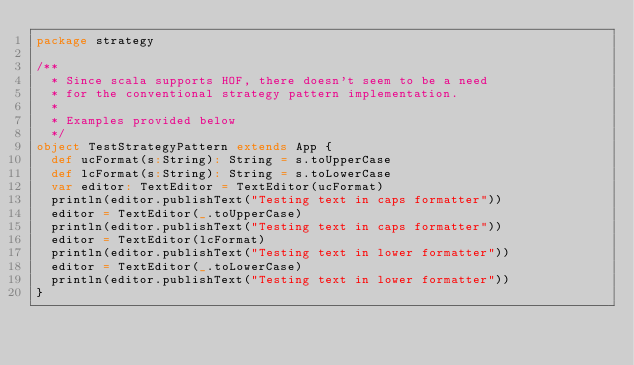Convert code to text. <code><loc_0><loc_0><loc_500><loc_500><_Scala_>package strategy

/**
  * Since scala supports HOF, there doesn't seem to be a need
  * for the conventional strategy pattern implementation.
  *
  * Examples provided below
  */
object TestStrategyPattern extends App {
  def ucFormat(s:String): String = s.toUpperCase
  def lcFormat(s:String): String = s.toLowerCase
  var editor: TextEditor = TextEditor(ucFormat)
  println(editor.publishText("Testing text in caps formatter"))
  editor = TextEditor(_.toUpperCase)
  println(editor.publishText("Testing text in caps formatter"))
  editor = TextEditor(lcFormat)
  println(editor.publishText("Testing text in lower formatter"))
  editor = TextEditor(_.toLowerCase)
  println(editor.publishText("Testing text in lower formatter"))
}
</code> 